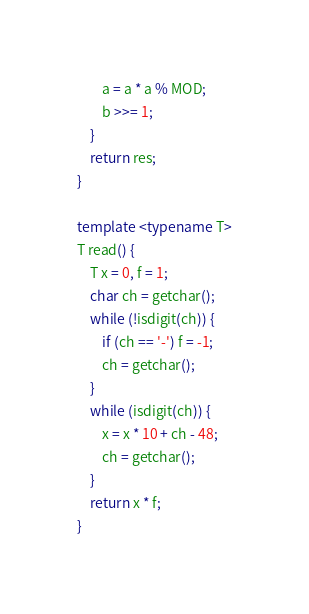<code> <loc_0><loc_0><loc_500><loc_500><_C++_>        a = a * a % MOD;
        b >>= 1;
    }
    return res;
}

template <typename T>
T read() {
    T x = 0, f = 1;
    char ch = getchar();
    while (!isdigit(ch)) {
        if (ch == '-') f = -1;
        ch = getchar();
    }
    while (isdigit(ch)) {
        x = x * 10 + ch - 48;
        ch = getchar();
    }
    return x * f;
}</code> 